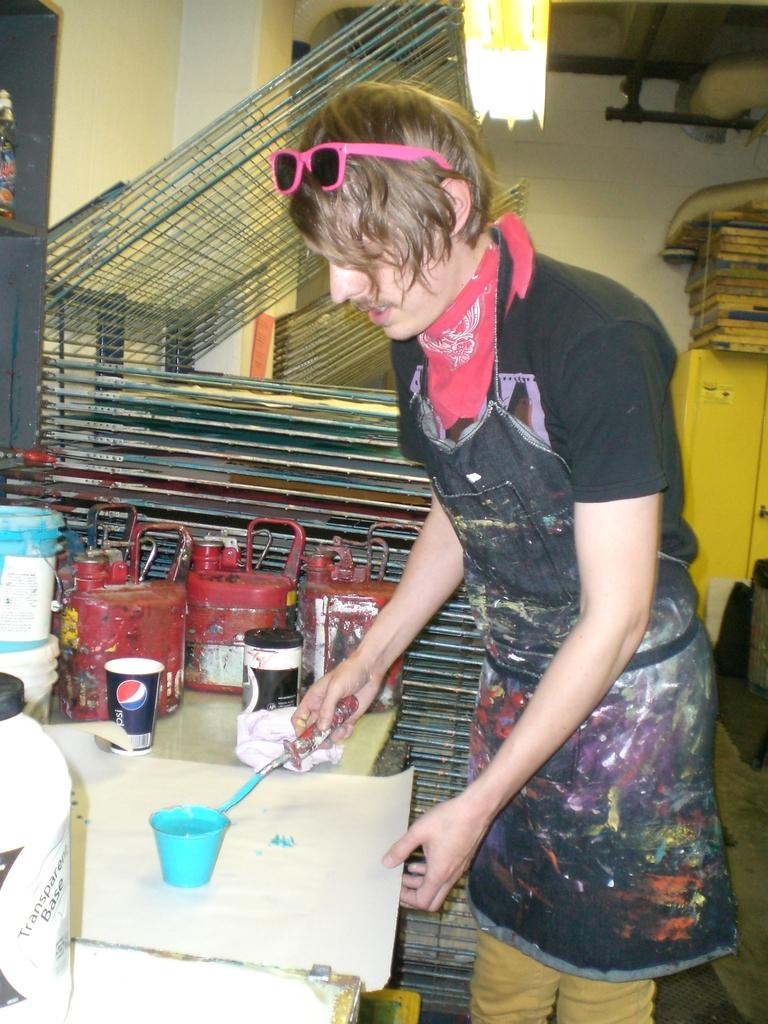Who is present in the image? There is a man in the image. What is the man holding in his hand? The man is holding a paper and a stick in his hand. What objects can be seen on the table in the image? There are cups and cans on the table in the image. What type of doctor is present in the image? There is no doctor present in the image; it only features a man holding a paper and a stick. Can you see any wrens in the image? There are no wrens present in the image. 